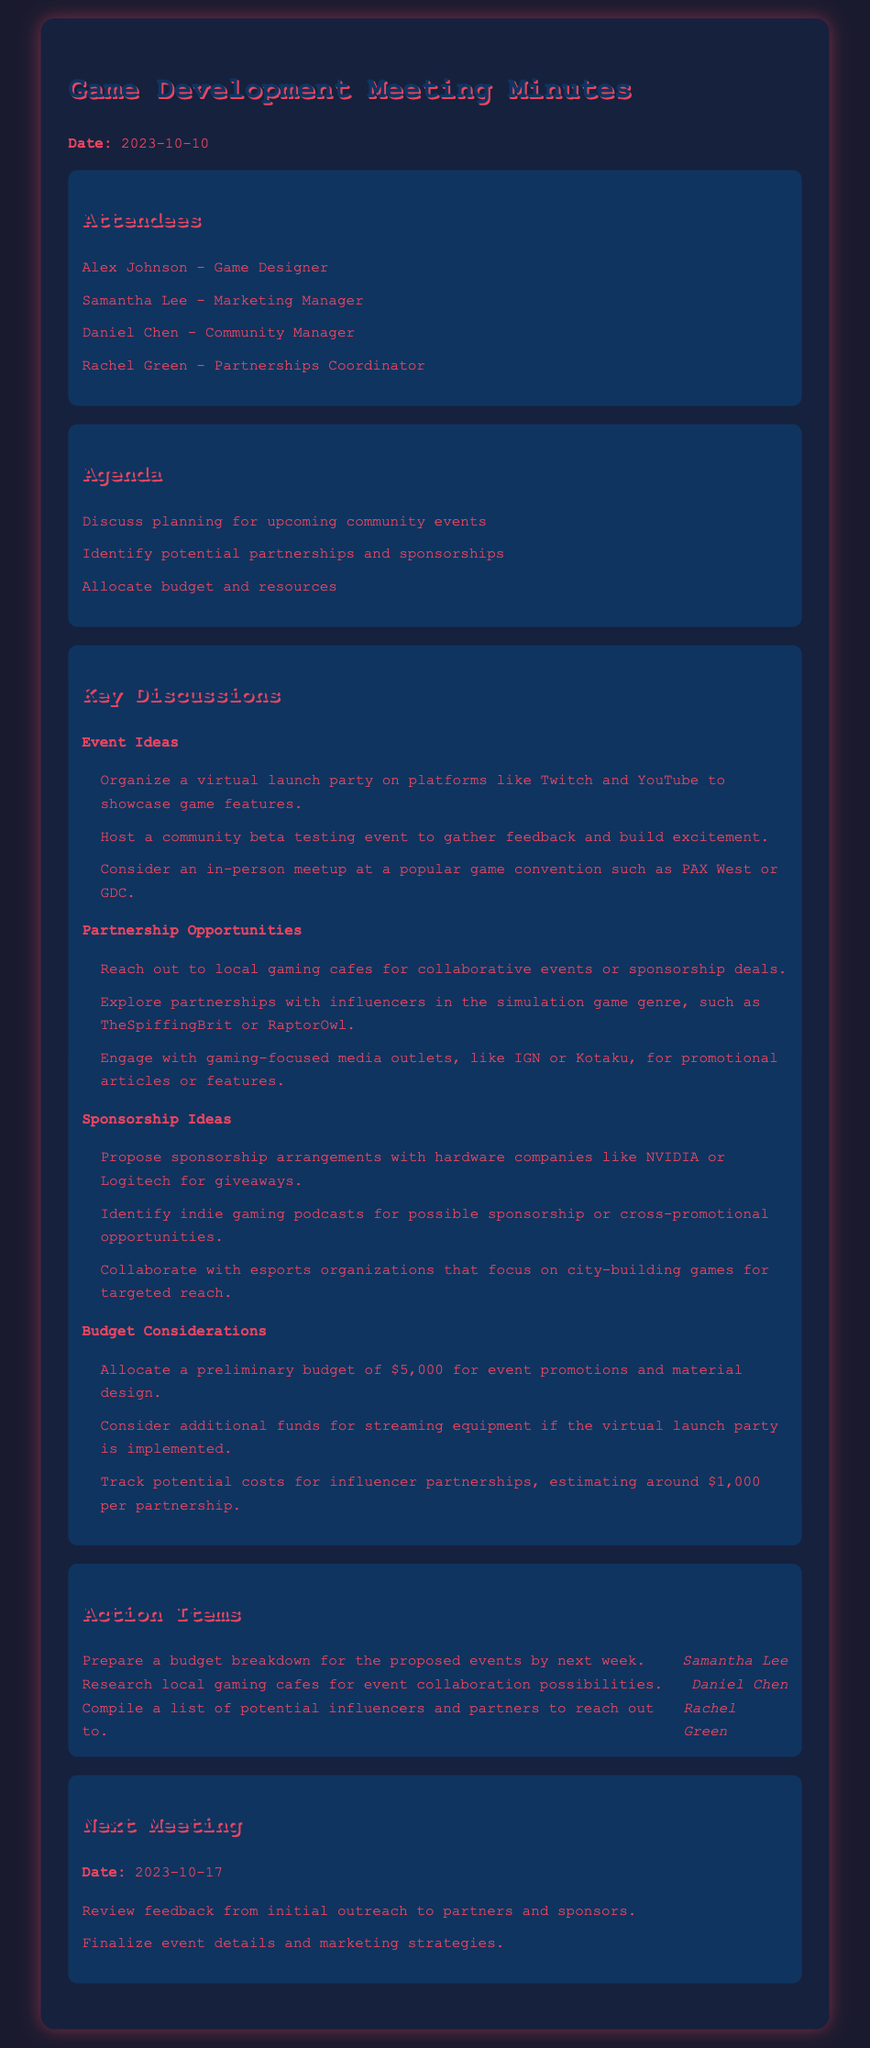What is the date of the meeting? The date of the meeting is stated at the beginning of the document.
Answer: 2023-10-10 Who is responsible for preparing the budget breakdown? The action items section lists the tasks and who is responsible for each task.
Answer: Samantha Lee What budget is allocated for event promotions? The budget considerations section mentions a preliminary budget for event promotions.
Answer: $5,000 What is one digital platform mentioned for the virtual launch party? The key discussions section lists platforms to showcase game features.
Answer: Twitch Which organization should be engaged for promotional articles? The partnership opportunities section includes potential media outlets to engage.
Answer: IGN How many days are there until the next meeting? The next meeting date is given, and one can calculate from the meeting date.
Answer: 7 days What type of events are suggested in the key discussions? The document lists specific event ideas under the key discussions section.
Answer: Community events What is the estimated cost for influencer partnerships? In the budget considerations, an estimate for this cost is provided.
Answer: $1,000 